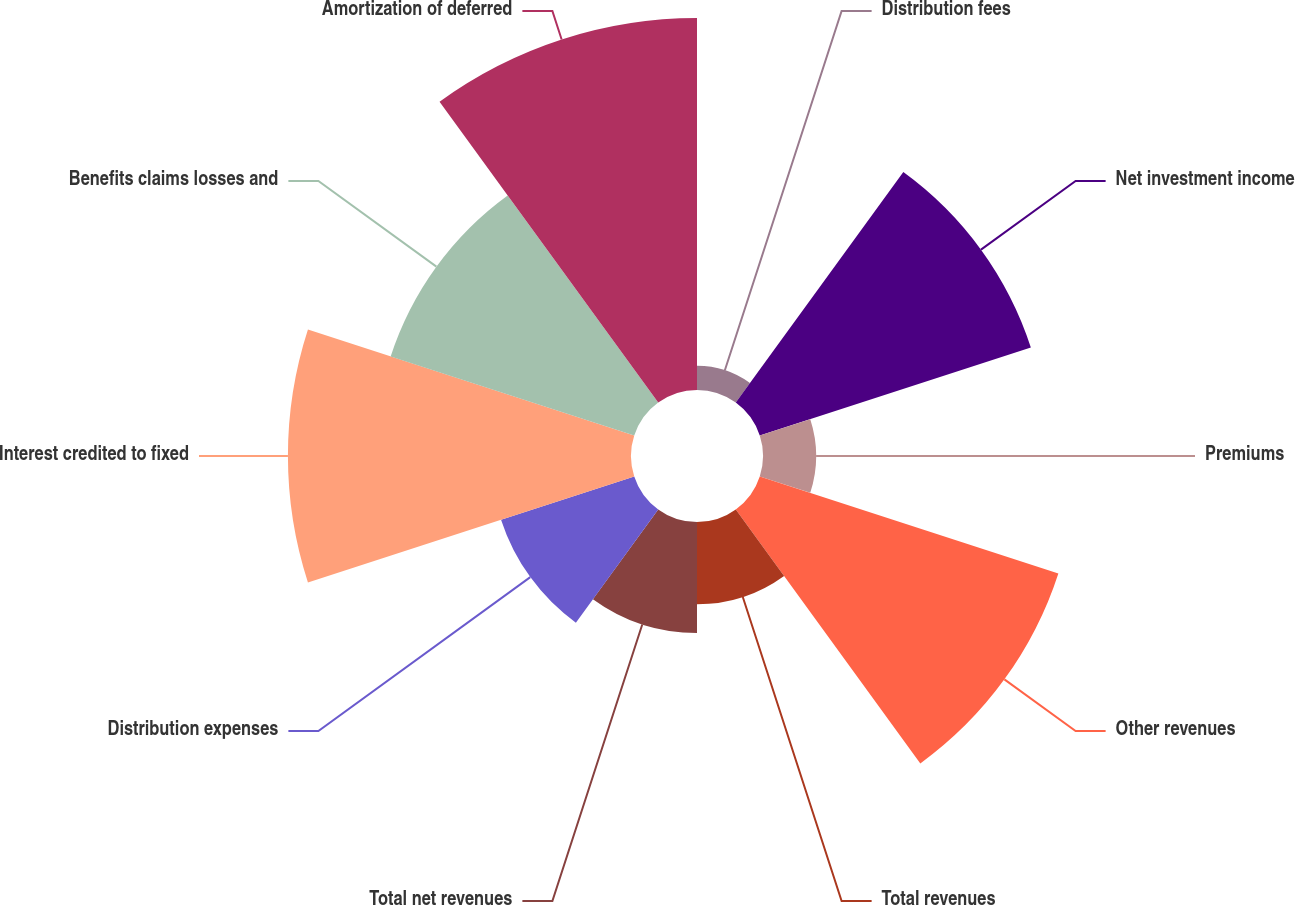<chart> <loc_0><loc_0><loc_500><loc_500><pie_chart><fcel>Distribution fees<fcel>Net investment income<fcel>Premiums<fcel>Other revenues<fcel>Total revenues<fcel>Total net revenues<fcel>Distribution expenses<fcel>Interest credited to fixed<fcel>Benefits claims losses and<fcel>Amortization of deferred<nl><fcel>1.22%<fcel>14.39%<fcel>2.68%<fcel>15.85%<fcel>4.15%<fcel>5.61%<fcel>7.07%<fcel>17.32%<fcel>12.93%<fcel>18.78%<nl></chart> 